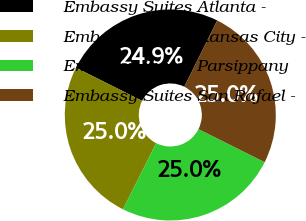Convert chart to OTSL. <chart><loc_0><loc_0><loc_500><loc_500><pie_chart><fcel>Embassy Suites Atlanta -<fcel>Embassy Suites Kansas City -<fcel>Embassy Suites Parsippany<fcel>Embassy Suites San Rafael -<nl><fcel>24.94%<fcel>24.99%<fcel>25.02%<fcel>25.04%<nl></chart> 